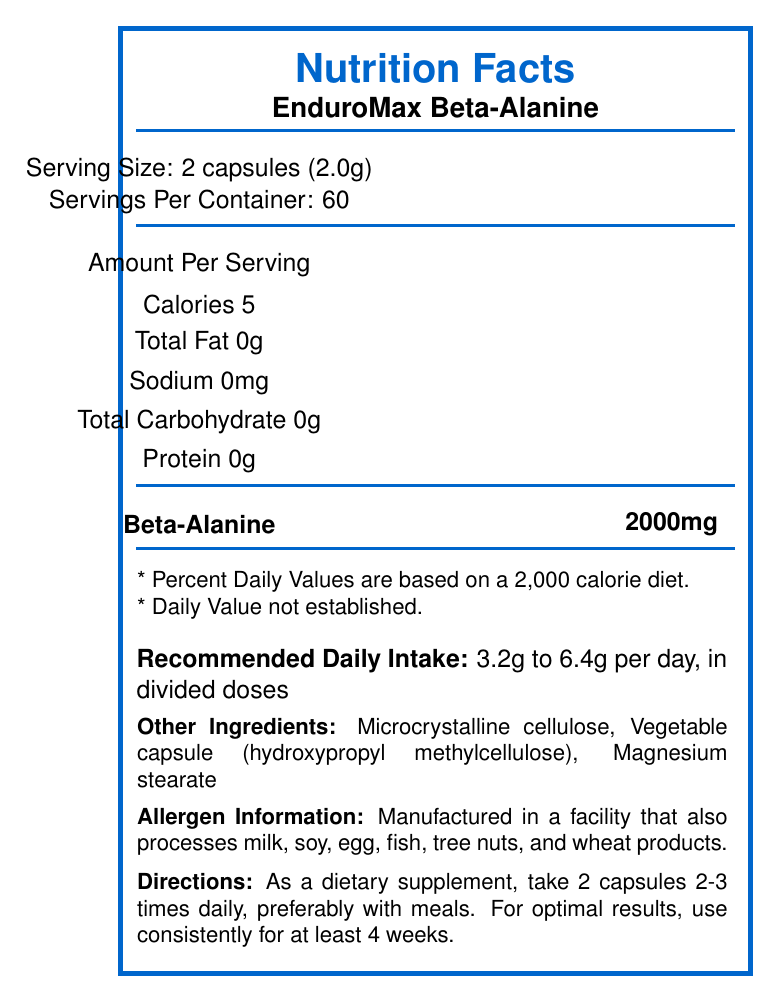what is the serving size for EnduroMax Beta-Alanine? The serving size is specified as 2 capsules (2.0g) in the document.
Answer: 2 capsules (2.0g) how many servings are in one container of EnduroMax Beta-Alanine? The document states that there are 60 servings per container.
Answer: 60 what is the recommended daily intake of EnduroMax Beta-Alanine? The recommended daily intake is 3.2g to 6.4g per day, taken in divided doses according to the document.
Answer: 3.2g to 6.4g per day, in divided doses describe the amount of beta-alanine per serving in EnduroMax Beta-Alanine The document specifies that there are 2000mg of beta-alanine per serving.
Answer: 2000mg what other ingredients are in EnduroMax Beta-Alanine capsules? These ingredients are listed under "Other Ingredients" in the document.
Answer: Microcrystalline cellulose, Vegetable capsule (hydroxypropyl methylcellulose), Magnesium stearate what are the calories per serving in EnduroMax Beta-Alanine? The document states that each serving has 5 calories.
Answer: 5 calories how frequently should the EnduroMax Beta-Alanine capsules be taken for optimal results? The directions recommend taking 2 capsules 2-3 times daily for optimal results.
Answer: 2 capsules 2-3 times daily, preferably with meals which of the following is included in the nutrition facts of EnduroMax Beta-Alanine?
A. Fiber
B. Beta-alanine
C. Vitamin D 
D. Calcium The nutrition facts include beta-alanine; fiber, vitamin D, and calcium are not listed in the document.
Answer: B what is the main function of beta-alanine mentioned in the document? The document explains that beta-alanine is shown to enhance muscular endurance and delay fatigue.
Answer: Enhance muscular endurance and delay fatigue in high-intensity exercise lasting 1-4 minutes which of these allergens is not explicitly stated as processed in the facility where EnduroMax Beta-Alanine is manufactured?
I. Milk
II. Soy
III. Peanuts
IV. Egg The document states the facility processes milk, soy, egg, fish, tree nuts, and wheat products, but not peanuts.
Answer: III is there any protein in each serving of EnduroMax Beta-Alanine? The document states that there is 0g of protein per serving.
Answer: No summarize the contents and main points of the Nutrition Facts Label for EnduroMax Beta-Alanine. This summary covers all the key elements, including serving size, servings per container, nutritional content, recommended daily intake, other ingredients, allergen information, directions for use, and the main function of beta-alanine.
Answer: The Nutrition Facts Label for EnduroMax Beta-Alanine highlights a serving size of 2 capsules (2.0g) and 60 servings per container. Each serving provides 5 calories, 0g of total fat, 0mg of sodium, 0g of carbohydrates, 0g of protein, and 2000mg of beta-alanine. The recommended daily intake is 3.2g to 6.4g per day in divided doses. Other ingredients include microcrystalline cellulose, vegetable capsule (hydroxypropyl methylcellulose), and magnesium stearate. The product is manufactured in a facility that processes various allergens, and directions suggest taking 2 capsules 2-3 times daily with meals. The label also mentions that beta-alanine enhances muscular endurance and delays fatigue. what is the expiration date of the Beta-Alanine capsules? The document mentions the expiration date is on the bottom of the bottle, but no specific date is provided in the visual information.
Answer: Not enough information 